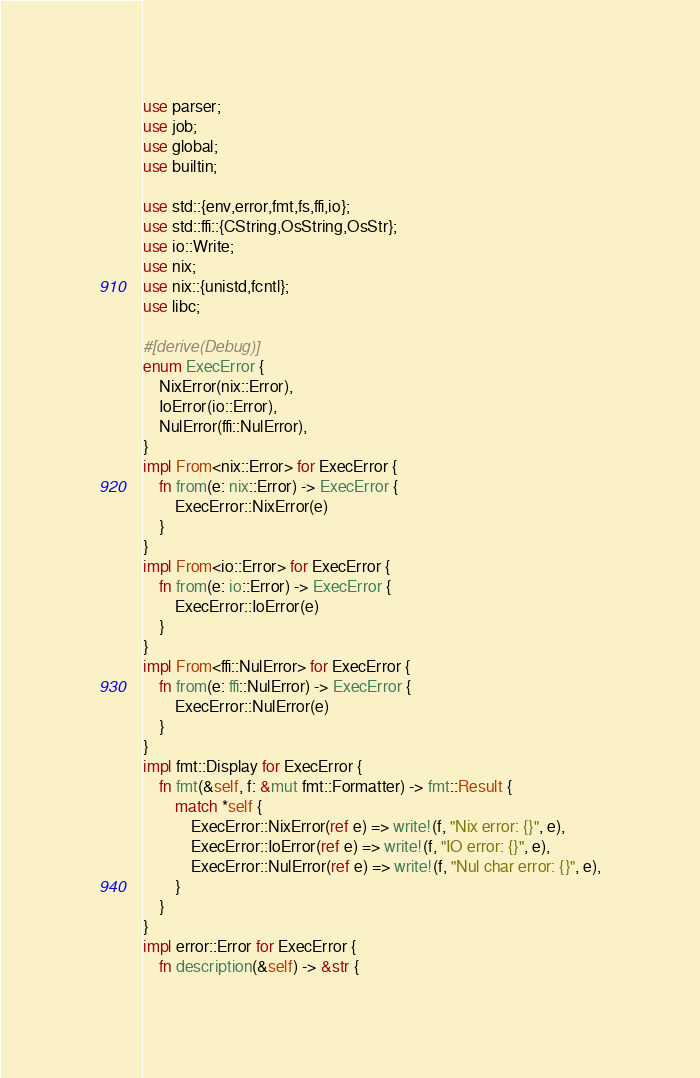<code> <loc_0><loc_0><loc_500><loc_500><_Rust_>use parser;
use job;
use global;
use builtin;

use std::{env,error,fmt,fs,ffi,io};
use std::ffi::{CString,OsString,OsStr};
use io::Write;
use nix;
use nix::{unistd,fcntl};
use libc;

#[derive(Debug)]
enum ExecError {
	NixError(nix::Error),
	IoError(io::Error),
	NulError(ffi::NulError),
}
impl From<nix::Error> for ExecError {
	fn from(e: nix::Error) -> ExecError {
		ExecError::NixError(e)
	}
}
impl From<io::Error> for ExecError {
	fn from(e: io::Error) -> ExecError {
		ExecError::IoError(e)
	}
}
impl From<ffi::NulError> for ExecError {
	fn from(e: ffi::NulError) -> ExecError {
		ExecError::NulError(e)
	}
}
impl fmt::Display for ExecError {
	fn fmt(&self, f: &mut fmt::Formatter) -> fmt::Result {
		match *self {
			ExecError::NixError(ref e) => write!(f, "Nix error: {}", e),
			ExecError::IoError(ref e) => write!(f, "IO error: {}", e),
			ExecError::NulError(ref e) => write!(f, "Nul char error: {}", e),
		}
	}
}
impl error::Error for ExecError {
	fn description(&self) -> &str {</code> 